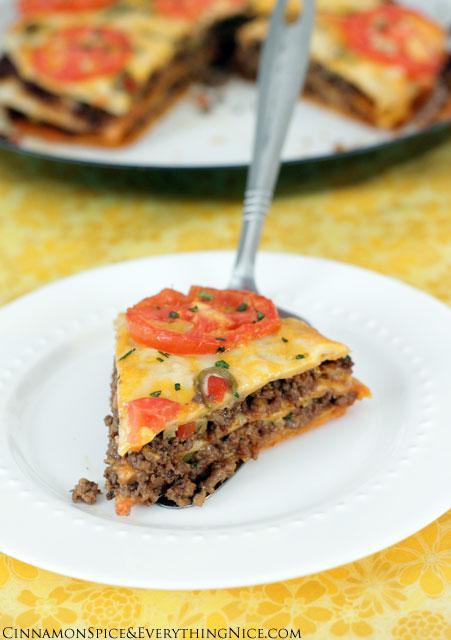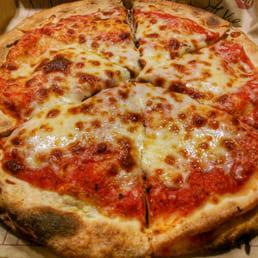The first image is the image on the left, the second image is the image on the right. Examine the images to the left and right. Is the description "There are three layers of pizza with at least one slice removed from the pie." accurate? Answer yes or no. No. The first image is the image on the left, the second image is the image on the right. Examine the images to the left and right. Is the description "The right image shows one slice missing from a stuffed pizza, and the left image features at least one sliced pizza with no slices missing." accurate? Answer yes or no. No. 